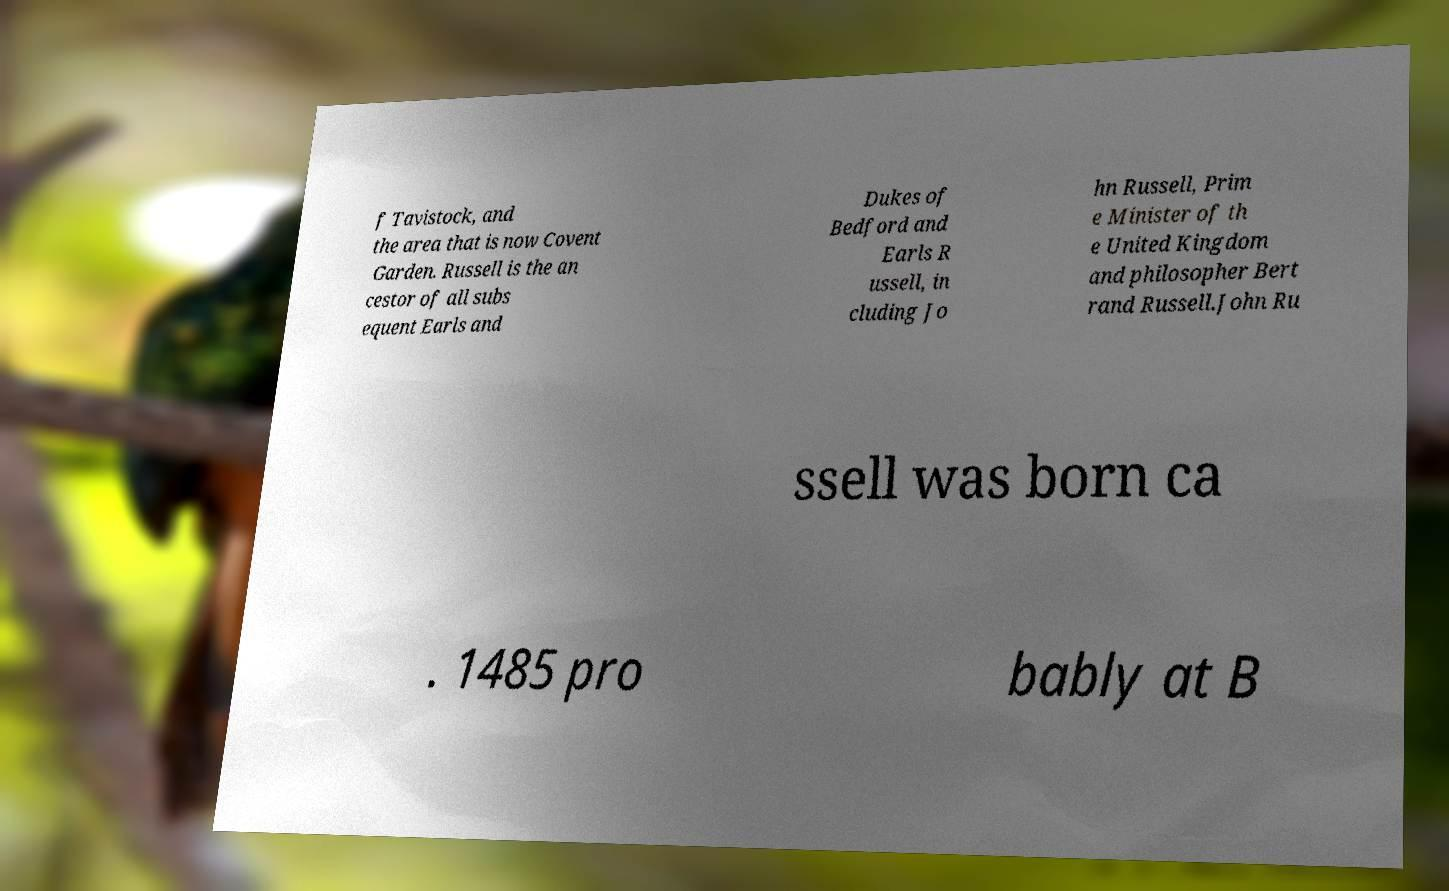Can you accurately transcribe the text from the provided image for me? f Tavistock, and the area that is now Covent Garden. Russell is the an cestor of all subs equent Earls and Dukes of Bedford and Earls R ussell, in cluding Jo hn Russell, Prim e Minister of th e United Kingdom and philosopher Bert rand Russell.John Ru ssell was born ca . 1485 pro bably at B 